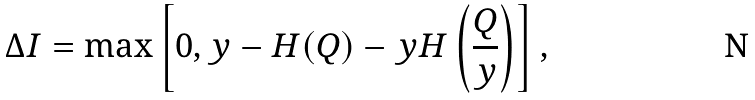Convert formula to latex. <formula><loc_0><loc_0><loc_500><loc_500>\Delta I = \max \left [ 0 , y - H ( Q ) - y H \left ( \frac { Q } { y } \right ) \right ] ,</formula> 